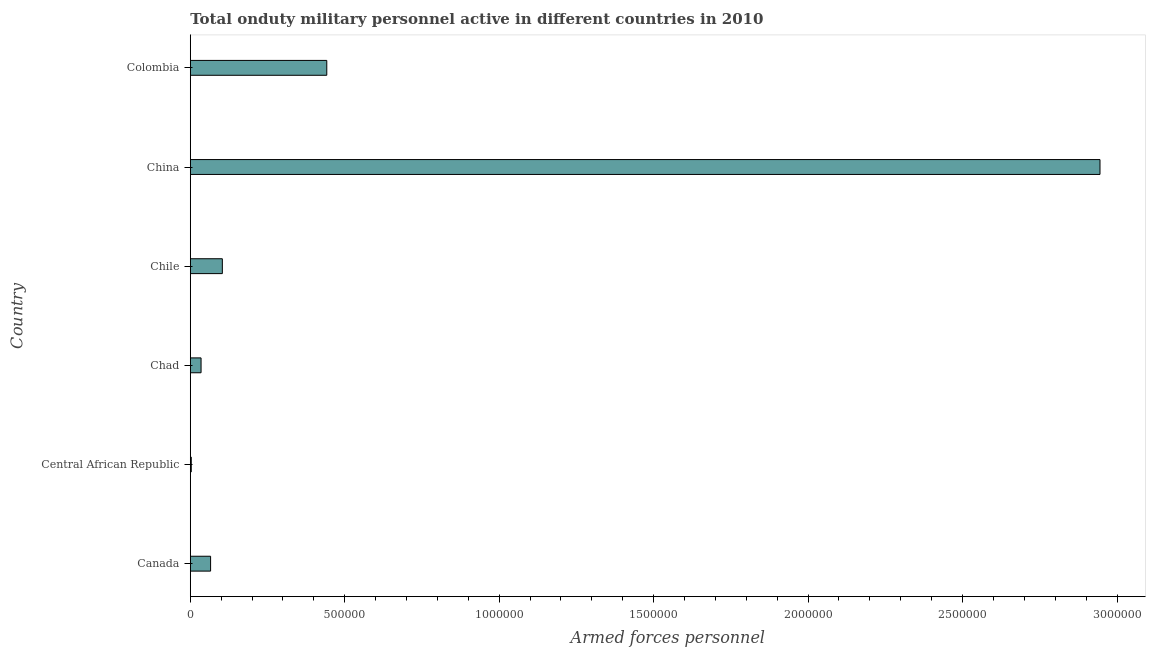Does the graph contain grids?
Give a very brief answer. No. What is the title of the graph?
Offer a very short reply. Total onduty military personnel active in different countries in 2010. What is the label or title of the X-axis?
Ensure brevity in your answer.  Armed forces personnel. What is the number of armed forces personnel in Colombia?
Keep it short and to the point. 4.42e+05. Across all countries, what is the maximum number of armed forces personnel?
Ensure brevity in your answer.  2.94e+06. Across all countries, what is the minimum number of armed forces personnel?
Provide a succinct answer. 3150. In which country was the number of armed forces personnel minimum?
Provide a short and direct response. Central African Republic. What is the sum of the number of armed forces personnel?
Provide a short and direct response. 3.59e+06. What is the difference between the number of armed forces personnel in Canada and Chad?
Provide a short and direct response. 3.08e+04. What is the average number of armed forces personnel per country?
Your response must be concise. 5.99e+05. What is the median number of armed forces personnel?
Provide a short and direct response. 8.47e+04. In how many countries, is the number of armed forces personnel greater than 1500000 ?
Keep it short and to the point. 1. What is the ratio of the number of armed forces personnel in Central African Republic to that in Colombia?
Make the answer very short. 0.01. Is the number of armed forces personnel in Canada less than that in Chad?
Give a very brief answer. No. What is the difference between the highest and the second highest number of armed forces personnel?
Make the answer very short. 2.50e+06. Is the sum of the number of armed forces personnel in Central African Republic and Colombia greater than the maximum number of armed forces personnel across all countries?
Keep it short and to the point. No. What is the difference between the highest and the lowest number of armed forces personnel?
Ensure brevity in your answer.  2.94e+06. What is the Armed forces personnel of Canada?
Your answer should be very brief. 6.57e+04. What is the Armed forces personnel in Central African Republic?
Your response must be concise. 3150. What is the Armed forces personnel of Chad?
Make the answer very short. 3.48e+04. What is the Armed forces personnel of Chile?
Keep it short and to the point. 1.04e+05. What is the Armed forces personnel of China?
Provide a succinct answer. 2.94e+06. What is the Armed forces personnel in Colombia?
Offer a terse response. 4.42e+05. What is the difference between the Armed forces personnel in Canada and Central African Republic?
Offer a very short reply. 6.26e+04. What is the difference between the Armed forces personnel in Canada and Chad?
Your response must be concise. 3.08e+04. What is the difference between the Armed forces personnel in Canada and Chile?
Provide a succinct answer. -3.81e+04. What is the difference between the Armed forces personnel in Canada and China?
Provide a short and direct response. -2.88e+06. What is the difference between the Armed forces personnel in Canada and Colombia?
Your answer should be compact. -3.76e+05. What is the difference between the Armed forces personnel in Central African Republic and Chad?
Offer a very short reply. -3.17e+04. What is the difference between the Armed forces personnel in Central African Republic and Chile?
Offer a very short reply. -1.01e+05. What is the difference between the Armed forces personnel in Central African Republic and China?
Offer a terse response. -2.94e+06. What is the difference between the Armed forces personnel in Central African Republic and Colombia?
Ensure brevity in your answer.  -4.39e+05. What is the difference between the Armed forces personnel in Chad and Chile?
Provide a succinct answer. -6.89e+04. What is the difference between the Armed forces personnel in Chad and China?
Your answer should be compact. -2.91e+06. What is the difference between the Armed forces personnel in Chad and Colombia?
Give a very brief answer. -4.07e+05. What is the difference between the Armed forces personnel in Chile and China?
Give a very brief answer. -2.84e+06. What is the difference between the Armed forces personnel in Chile and Colombia?
Provide a short and direct response. -3.38e+05. What is the difference between the Armed forces personnel in China and Colombia?
Your answer should be compact. 2.50e+06. What is the ratio of the Armed forces personnel in Canada to that in Central African Republic?
Provide a short and direct response. 20.86. What is the ratio of the Armed forces personnel in Canada to that in Chad?
Your answer should be compact. 1.89. What is the ratio of the Armed forces personnel in Canada to that in Chile?
Your response must be concise. 0.63. What is the ratio of the Armed forces personnel in Canada to that in China?
Your response must be concise. 0.02. What is the ratio of the Armed forces personnel in Canada to that in Colombia?
Ensure brevity in your answer.  0.15. What is the ratio of the Armed forces personnel in Central African Republic to that in Chad?
Make the answer very short. 0.09. What is the ratio of the Armed forces personnel in Central African Republic to that in China?
Your response must be concise. 0. What is the ratio of the Armed forces personnel in Central African Republic to that in Colombia?
Offer a terse response. 0.01. What is the ratio of the Armed forces personnel in Chad to that in Chile?
Make the answer very short. 0.34. What is the ratio of the Armed forces personnel in Chad to that in China?
Give a very brief answer. 0.01. What is the ratio of the Armed forces personnel in Chad to that in Colombia?
Keep it short and to the point. 0.08. What is the ratio of the Armed forces personnel in Chile to that in China?
Keep it short and to the point. 0.04. What is the ratio of the Armed forces personnel in Chile to that in Colombia?
Your response must be concise. 0.23. What is the ratio of the Armed forces personnel in China to that in Colombia?
Ensure brevity in your answer.  6.67. 